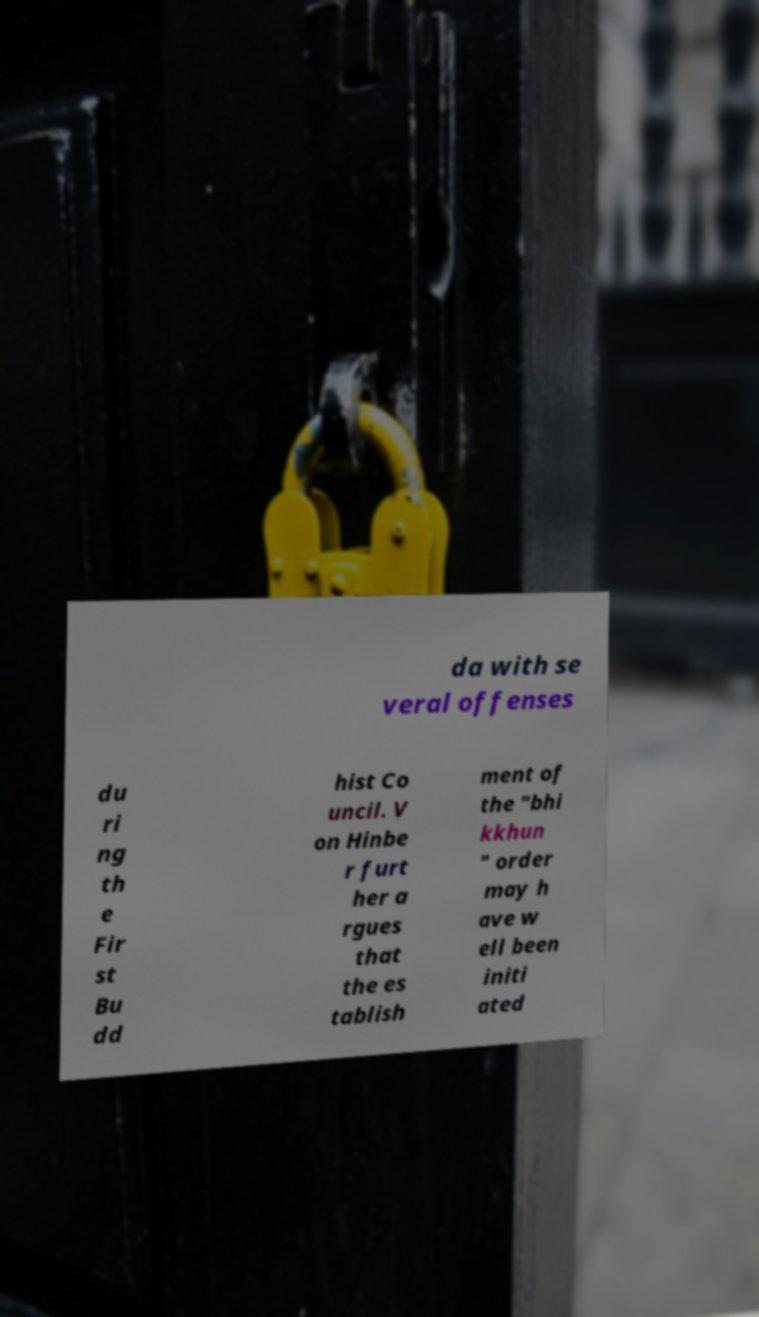Could you assist in decoding the text presented in this image and type it out clearly? da with se veral offenses du ri ng th e Fir st Bu dd hist Co uncil. V on Hinbe r furt her a rgues that the es tablish ment of the "bhi kkhun " order may h ave w ell been initi ated 